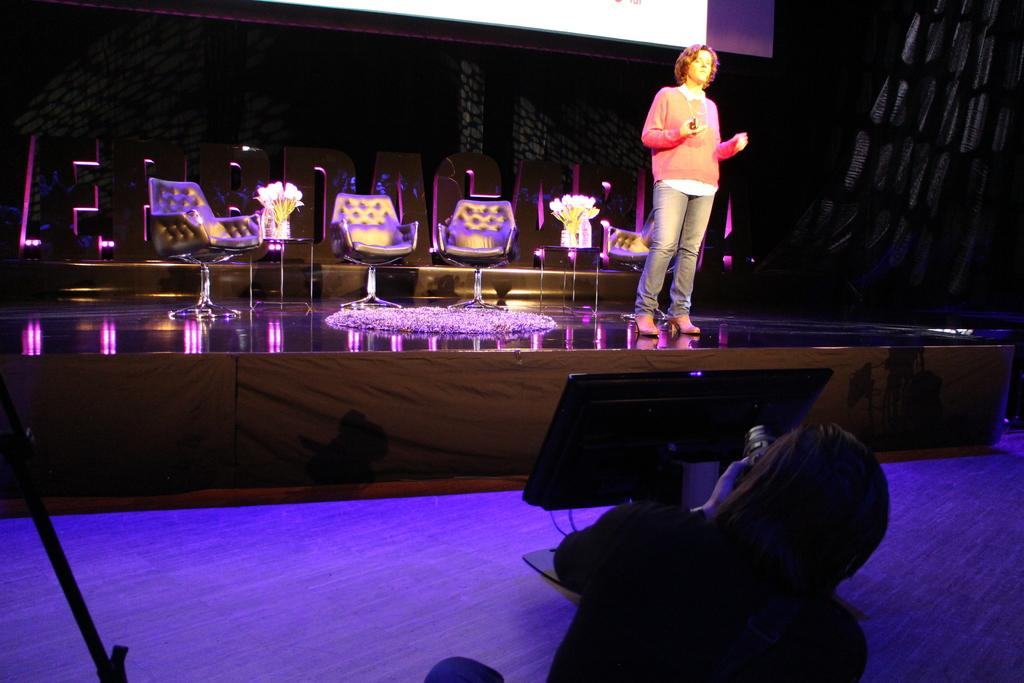What is the woman doing on the stage in the image? The woman is standing on the stage in the image. What can be seen behind the stage? Chairs are arranged behind the stage. Are there any decorative elements among the arranged chairs? Yes, there are potted plants among the arranged chairs. Can you describe the action of one person in the image? One person is sitting down and taking a picture. What story is the woman telling the chairs in the image? There is no indication in the image that the woman is telling a story to the chairs, as she is standing on the stage and not interacting with them. 